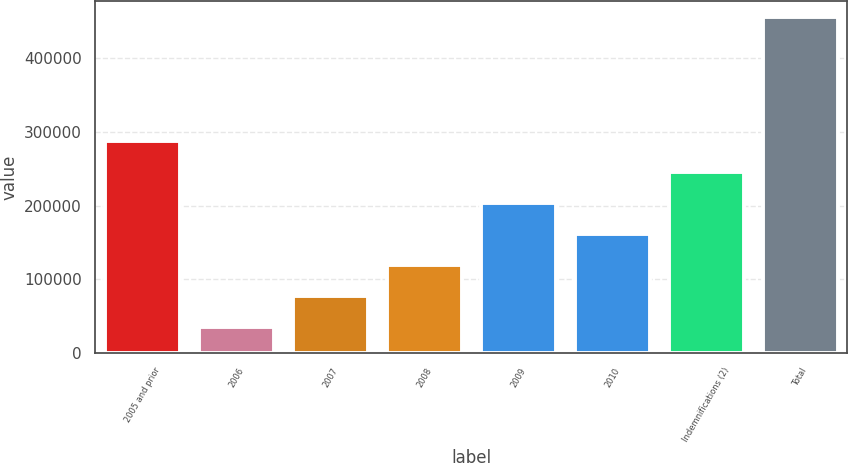Convert chart to OTSL. <chart><loc_0><loc_0><loc_500><loc_500><bar_chart><fcel>2005 and prior<fcel>2006<fcel>2007<fcel>2008<fcel>2009<fcel>2010<fcel>Indemnifications (2)<fcel>Total<nl><fcel>287452<fcel>34969<fcel>77049.5<fcel>119130<fcel>203291<fcel>161210<fcel>245372<fcel>455774<nl></chart> 